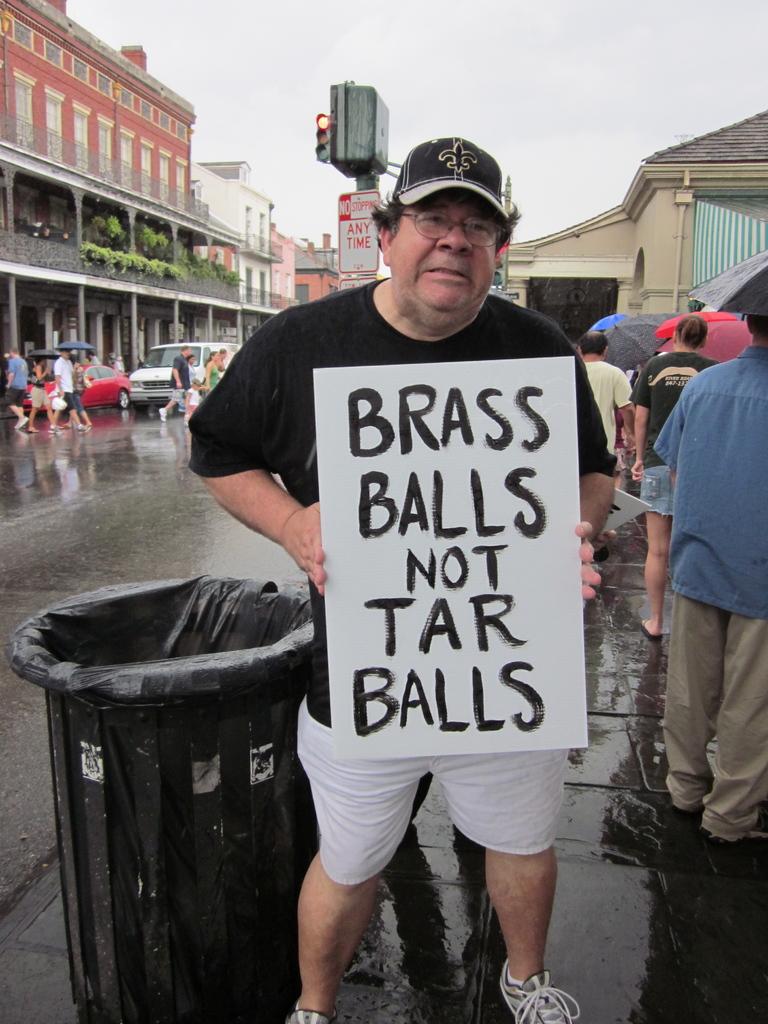What kind of balls is this guy calling for?
Your response must be concise. Brass. What is written on this guy's sign?
Your answer should be compact. Brass balls not tar balls. 